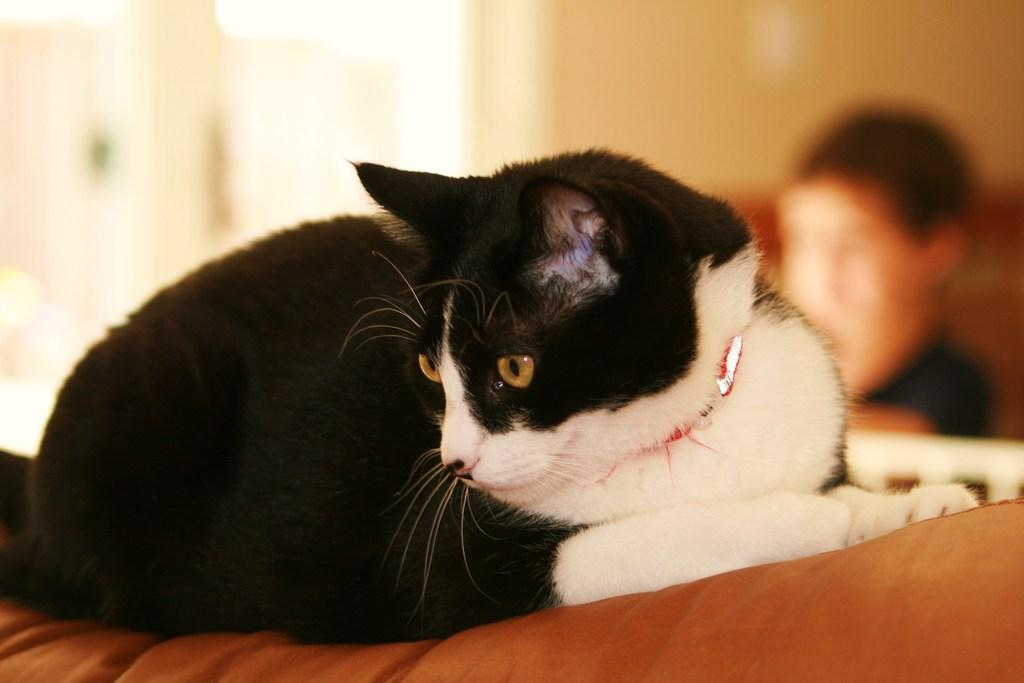What type of animal is present in the image? There is a cat in the image. Can you describe the background of the image? The background of the image is blurred. What other subject is present in the image besides the cat? There is a person in the image. What type of discussion is taking place between the cat and the person in the image? There is no discussion taking place between the cat and the person in the image, as animals do not engage in verbal discussions with humans. Can you see any dirt or stains on the cat or the person in the image? The provided facts do not mention any dirt or stains on the cat or the person in the image. 